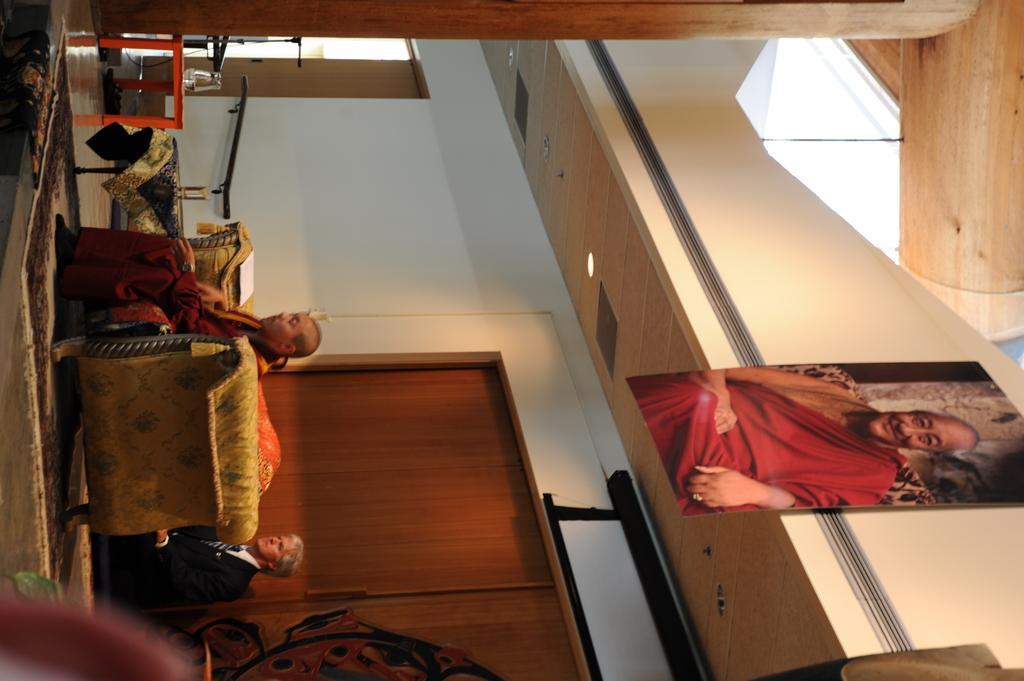Can you describe this image briefly? This image is in the right direction. On the left side, I can see a person is sitting on a couch. At the back of the couch there is another person wearing black color suit. There are few objects on the floor. In the back of these people I can see the wall. On the right side there is a photo frame of a person which is attached to the wall. 